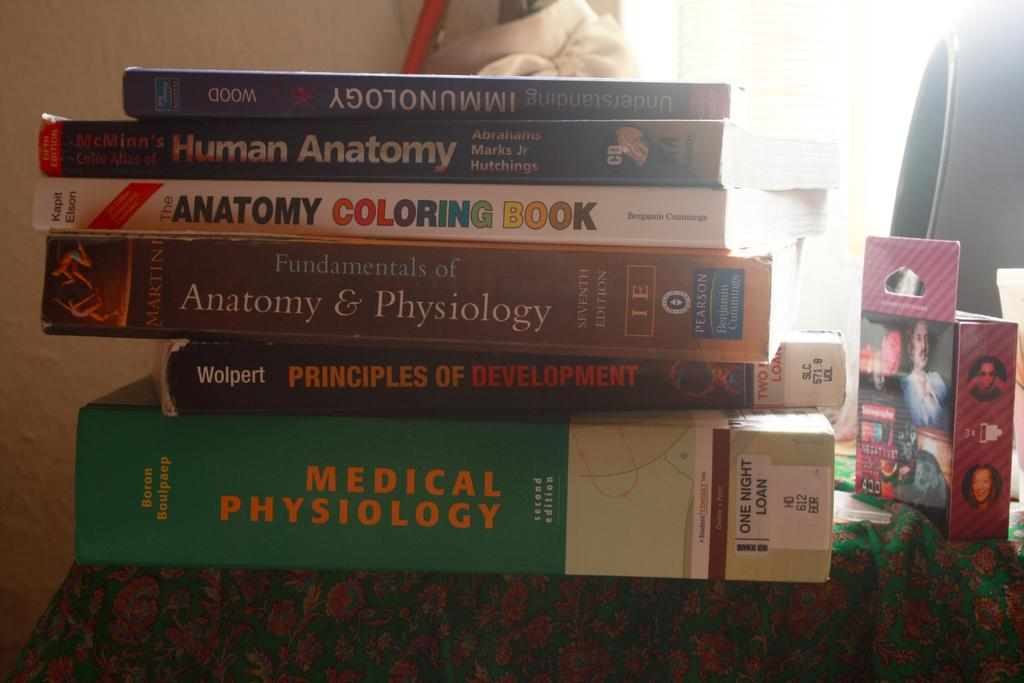Provide a one-sentence caption for the provided image. Medical Phsyiology book on bottom and Immunology book in blue on top. 